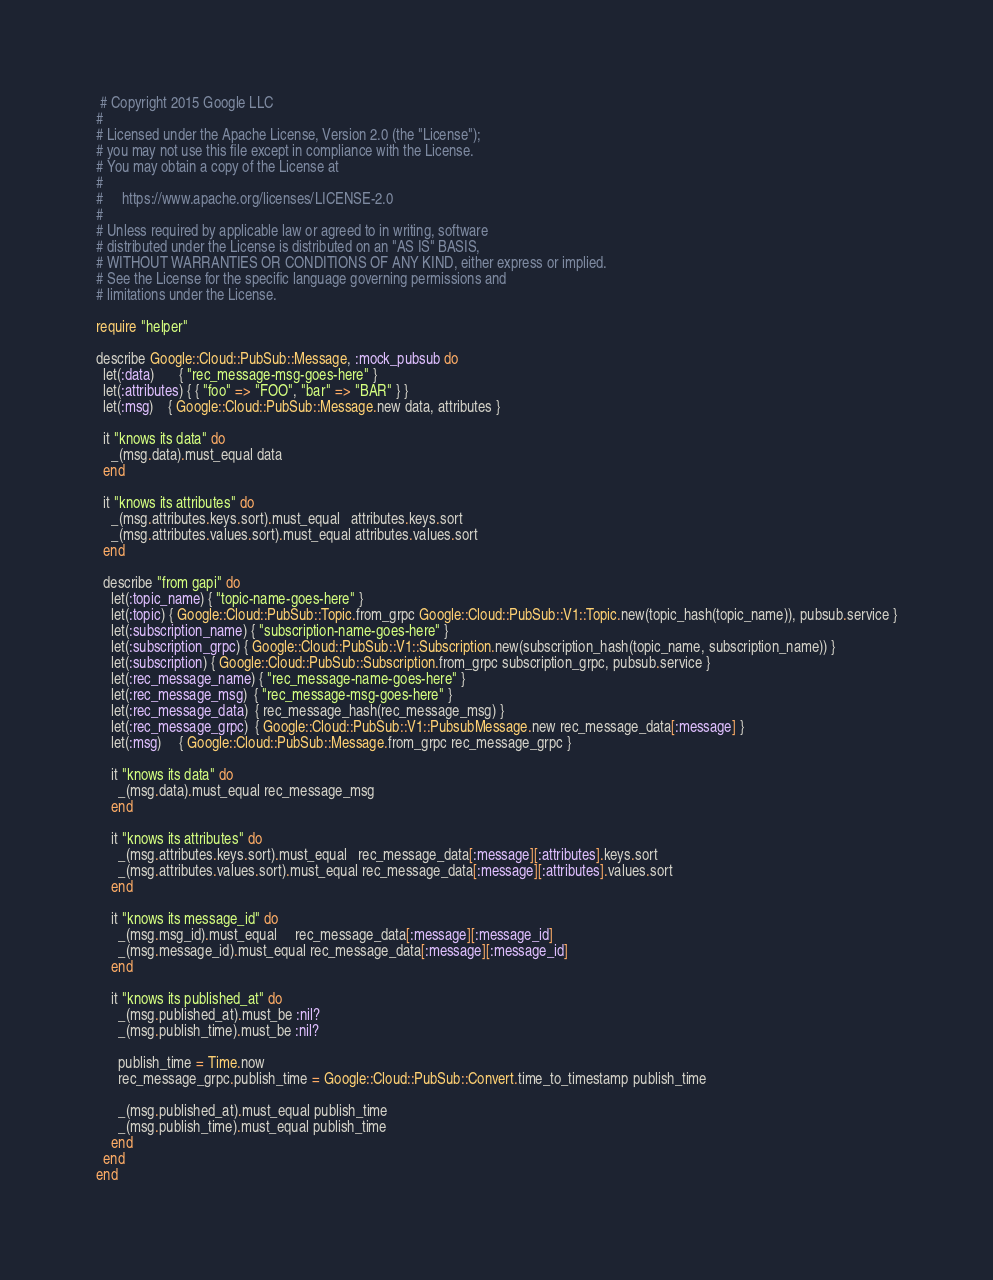<code> <loc_0><loc_0><loc_500><loc_500><_Ruby_> # Copyright 2015 Google LLC
#
# Licensed under the Apache License, Version 2.0 (the "License");
# you may not use this file except in compliance with the License.
# You may obtain a copy of the License at
#
#     https://www.apache.org/licenses/LICENSE-2.0
#
# Unless required by applicable law or agreed to in writing, software
# distributed under the License is distributed on an "AS IS" BASIS,
# WITHOUT WARRANTIES OR CONDITIONS OF ANY KIND, either express or implied.
# See the License for the specific language governing permissions and
# limitations under the License.

require "helper"

describe Google::Cloud::PubSub::Message, :mock_pubsub do
  let(:data)       { "rec_message-msg-goes-here" }
  let(:attributes) { { "foo" => "FOO", "bar" => "BAR" } }
  let(:msg)    { Google::Cloud::PubSub::Message.new data, attributes }

  it "knows its data" do
    _(msg.data).must_equal data
  end

  it "knows its attributes" do
    _(msg.attributes.keys.sort).must_equal   attributes.keys.sort
    _(msg.attributes.values.sort).must_equal attributes.values.sort
  end

  describe "from gapi" do
    let(:topic_name) { "topic-name-goes-here" }
    let(:topic) { Google::Cloud::PubSub::Topic.from_grpc Google::Cloud::PubSub::V1::Topic.new(topic_hash(topic_name)), pubsub.service }
    let(:subscription_name) { "subscription-name-goes-here" }
    let(:subscription_grpc) { Google::Cloud::PubSub::V1::Subscription.new(subscription_hash(topic_name, subscription_name)) }
    let(:subscription) { Google::Cloud::PubSub::Subscription.from_grpc subscription_grpc, pubsub.service }
    let(:rec_message_name) { "rec_message-name-goes-here" }
    let(:rec_message_msg)  { "rec_message-msg-goes-here" }
    let(:rec_message_data)  { rec_message_hash(rec_message_msg) }
    let(:rec_message_grpc)  { Google::Cloud::PubSub::V1::PubsubMessage.new rec_message_data[:message] }
    let(:msg)     { Google::Cloud::PubSub::Message.from_grpc rec_message_grpc }

    it "knows its data" do
      _(msg.data).must_equal rec_message_msg
    end

    it "knows its attributes" do
      _(msg.attributes.keys.sort).must_equal   rec_message_data[:message][:attributes].keys.sort
      _(msg.attributes.values.sort).must_equal rec_message_data[:message][:attributes].values.sort
    end

    it "knows its message_id" do
      _(msg.msg_id).must_equal     rec_message_data[:message][:message_id]
      _(msg.message_id).must_equal rec_message_data[:message][:message_id]
    end

    it "knows its published_at" do
      _(msg.published_at).must_be :nil?
      _(msg.publish_time).must_be :nil?

      publish_time = Time.now
      rec_message_grpc.publish_time = Google::Cloud::PubSub::Convert.time_to_timestamp publish_time

      _(msg.published_at).must_equal publish_time
      _(msg.publish_time).must_equal publish_time
    end
  end
end
</code> 